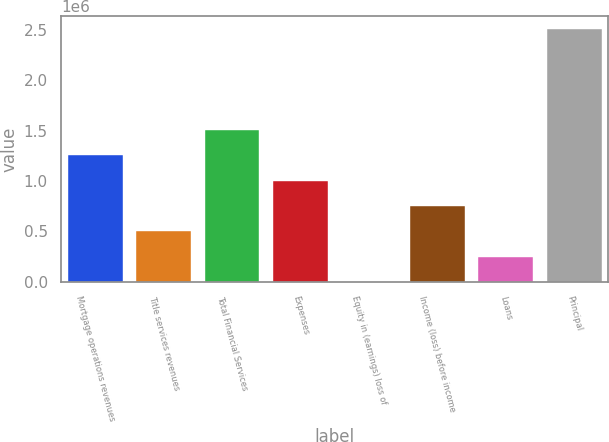Convert chart. <chart><loc_0><loc_0><loc_500><loc_500><bar_chart><fcel>Mortgage operations revenues<fcel>Title services revenues<fcel>Total Financial Services<fcel>Expenses<fcel>Equity in (earnings) loss of<fcel>Income (loss) before income<fcel>Loans<fcel>Principal<nl><fcel>1.25506e+06<fcel>502134<fcel>1.50603e+06<fcel>1.00408e+06<fcel>186<fcel>753109<fcel>251160<fcel>2.50993e+06<nl></chart> 